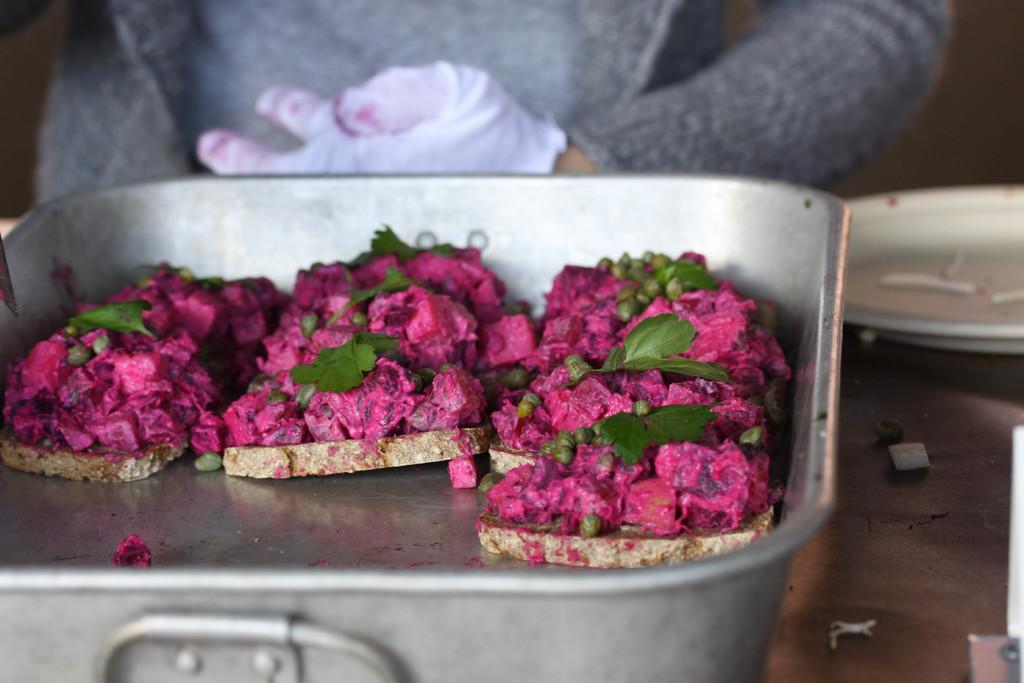What is the main subject in the front of the image? There is food in the front of the image. Can you describe anything in the background of the image? There is a person in the background of the image. What can be seen on the right side of the image? There are objects visible on the right side of the image. What type of brick is being used to hold the food in the image? There is no brick present in the image. The food is not being held by any brick. 